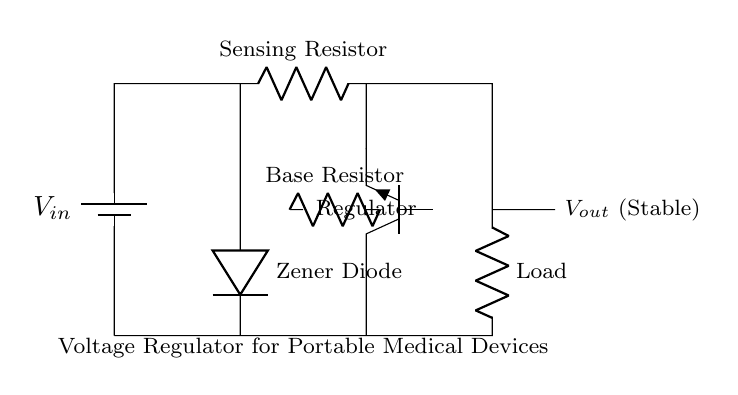What is the input voltage in this circuit? The input voltage is denoted as V_in, which is represented near the battery symbol.
Answer: V_in What component is used for voltage regulation? The regulator in this circuit is an NPN transistor labeled as "Regulator," which serves to control the output voltage.
Answer: Regulator What type of diode is used in this circuit? The Zener diode, indicated in the diagram, is specifically designed to maintain a stable output voltage despite variations in input voltage.
Answer: Zener Diode What is the purpose of the sensing resistor? The sensing resistor is used to monitor the current flowing through the circuit, providing feedback for voltage regulation.
Answer: Sensing Resistor How does the output voltage relate to the input voltage? The Zener diode and the voltage regulator work together to ensure that V_out remains stable and lower than V_in, preventing fluctuations that can affect medical devices.
Answer: Stable output What is the output voltage indicated in the circuit? The output voltage is denoted as V_out, which is labeled in the circuit as stable, reflecting the role of the regulator in maintaining this quality.
Answer: V_out (Stable) What does the load represent in this circuit? The load represents the device or components that consume power, which must receive a stable voltage for proper operation, such as a portable medical device.
Answer: Load 